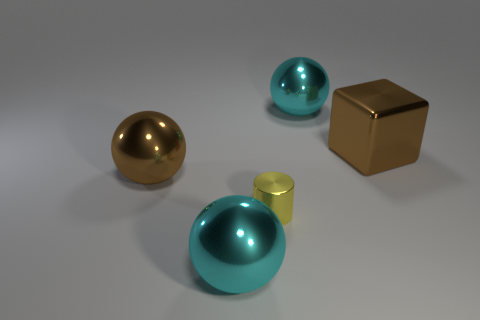Subtract all big cyan balls. How many balls are left? 1 Add 1 tiny brown blocks. How many objects exist? 6 Subtract all brown spheres. How many spheres are left? 2 Subtract all spheres. How many objects are left? 2 Subtract 1 spheres. How many spheres are left? 2 Subtract all cyan metal things. Subtract all large cyan metal objects. How many objects are left? 1 Add 3 yellow cylinders. How many yellow cylinders are left? 4 Add 4 purple balls. How many purple balls exist? 4 Subtract 0 purple blocks. How many objects are left? 5 Subtract all red balls. Subtract all gray blocks. How many balls are left? 3 